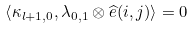Convert formula to latex. <formula><loc_0><loc_0><loc_500><loc_500>\left \langle \kappa _ { l + 1 , 0 } , \lambda _ { 0 , 1 } \otimes \widehat { e } ( i , j ) \right \rangle = 0</formula> 